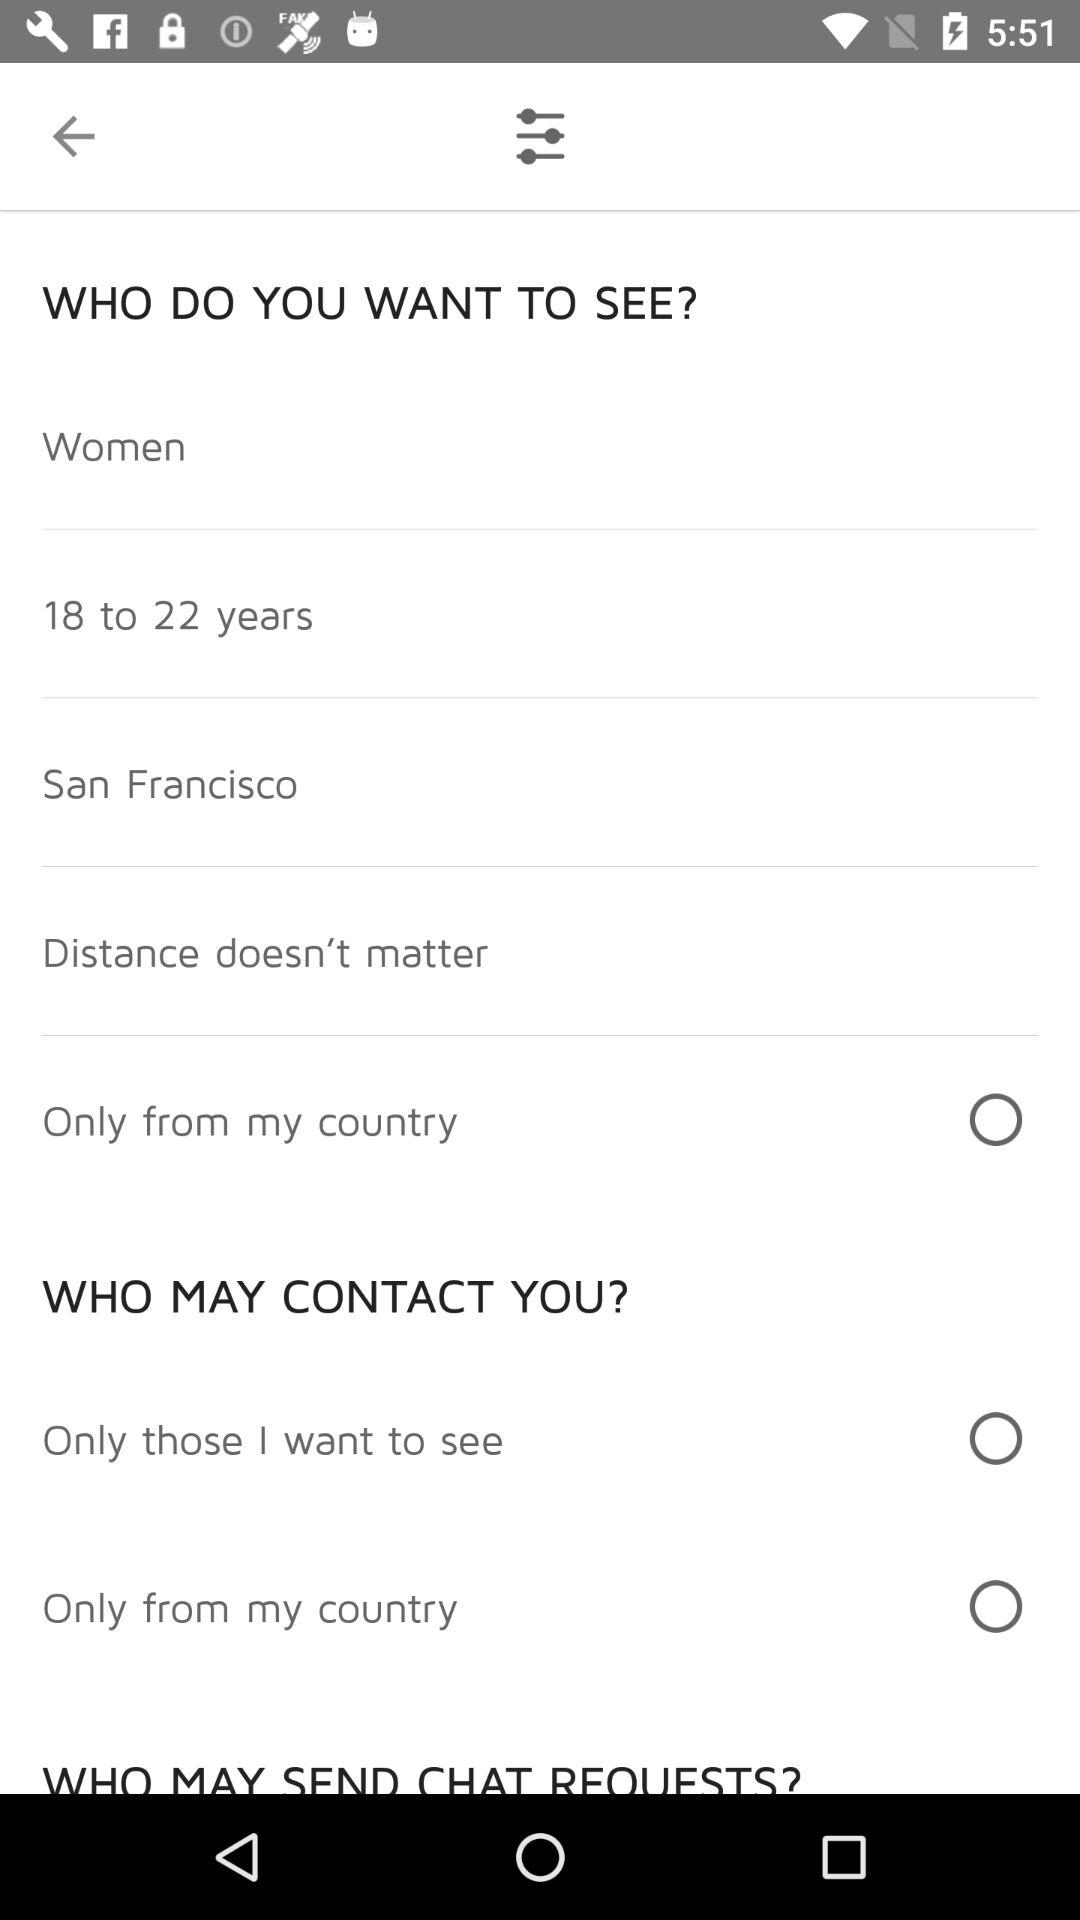What is the mentioned gender? The mentioned gender is women. 